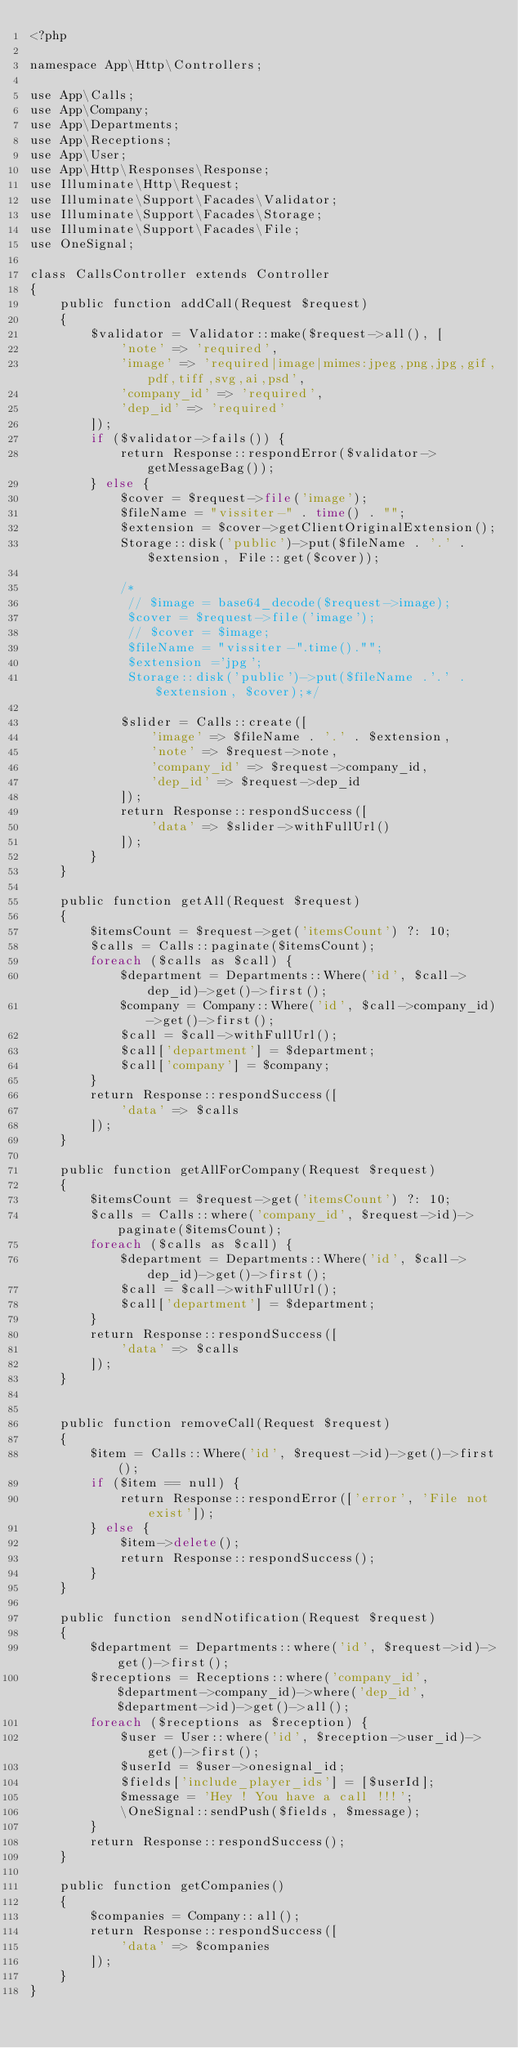<code> <loc_0><loc_0><loc_500><loc_500><_PHP_><?php

namespace App\Http\Controllers;

use App\Calls;
use App\Company;
use App\Departments;
use App\Receptions;
use App\User;
use App\Http\Responses\Response;
use Illuminate\Http\Request;
use Illuminate\Support\Facades\Validator;
use Illuminate\Support\Facades\Storage;
use Illuminate\Support\Facades\File;
use OneSignal;

class CallsController extends Controller
{
    public function addCall(Request $request)
    {
        $validator = Validator::make($request->all(), [
            'note' => 'required',
            'image' => 'required|image|mimes:jpeg,png,jpg,gif,pdf,tiff,svg,ai,psd',
            'company_id' => 'required',
            'dep_id' => 'required'
        ]);
        if ($validator->fails()) {
            return Response::respondError($validator->getMessageBag());
        } else {
            $cover = $request->file('image');
            $fileName = "vissiter-" . time() . "";
            $extension = $cover->getClientOriginalExtension();
            Storage::disk('public')->put($fileName . '.' . $extension, File::get($cover));

            /*
             // $image = base64_decode($request->image);
             $cover = $request->file('image');
             // $cover = $image;
             $fileName = "vissiter-".time()."";
             $extension ='jpg';
             Storage::disk('public')->put($fileName .'.' . $extension, $cover);*/

            $slider = Calls::create([
                'image' => $fileName . '.' . $extension,
                'note' => $request->note,
                'company_id' => $request->company_id,
                'dep_id' => $request->dep_id
            ]);
            return Response::respondSuccess([
                'data' => $slider->withFullUrl()
            ]);
        }
    }

    public function getAll(Request $request)
    {
        $itemsCount = $request->get('itemsCount') ?: 10;
        $calls = Calls::paginate($itemsCount);
        foreach ($calls as $call) {
            $department = Departments::Where('id', $call->dep_id)->get()->first();
            $company = Company::Where('id', $call->company_id)->get()->first();
            $call = $call->withFullUrl();
            $call['department'] = $department;
            $call['company'] = $company;
        }
        return Response::respondSuccess([
            'data' => $calls
        ]);
    }

    public function getAllForCompany(Request $request)
    {
        $itemsCount = $request->get('itemsCount') ?: 10;
        $calls = Calls::where('company_id', $request->id)->paginate($itemsCount);
        foreach ($calls as $call) {
            $department = Departments::Where('id', $call->dep_id)->get()->first();
            $call = $call->withFullUrl();
            $call['department'] = $department;
        }
        return Response::respondSuccess([
            'data' => $calls
        ]);
    }


    public function removeCall(Request $request)
    {
        $item = Calls::Where('id', $request->id)->get()->first();
        if ($item == null) {
            return Response::respondError(['error', 'File not exist']);
        } else {
            $item->delete();
            return Response::respondSuccess();
        }
    }

    public function sendNotification(Request $request)
    {
        $department = Departments::where('id', $request->id)->get()->first();
        $receptions = Receptions::where('company_id', $department->company_id)->where('dep_id', $department->id)->get()->all();
        foreach ($receptions as $reception) {
            $user = User::where('id', $reception->user_id)->get()->first();
            $userId = $user->onesignal_id;
            $fields['include_player_ids'] = [$userId];
            $message = 'Hey ! You have a call !!!';
            \OneSignal::sendPush($fields, $message);
        }
        return Response::respondSuccess();
    }

    public function getCompanies()
    {
        $companies = Company::all();
        return Response::respondSuccess([
            'data' => $companies
        ]);
    }
}
</code> 